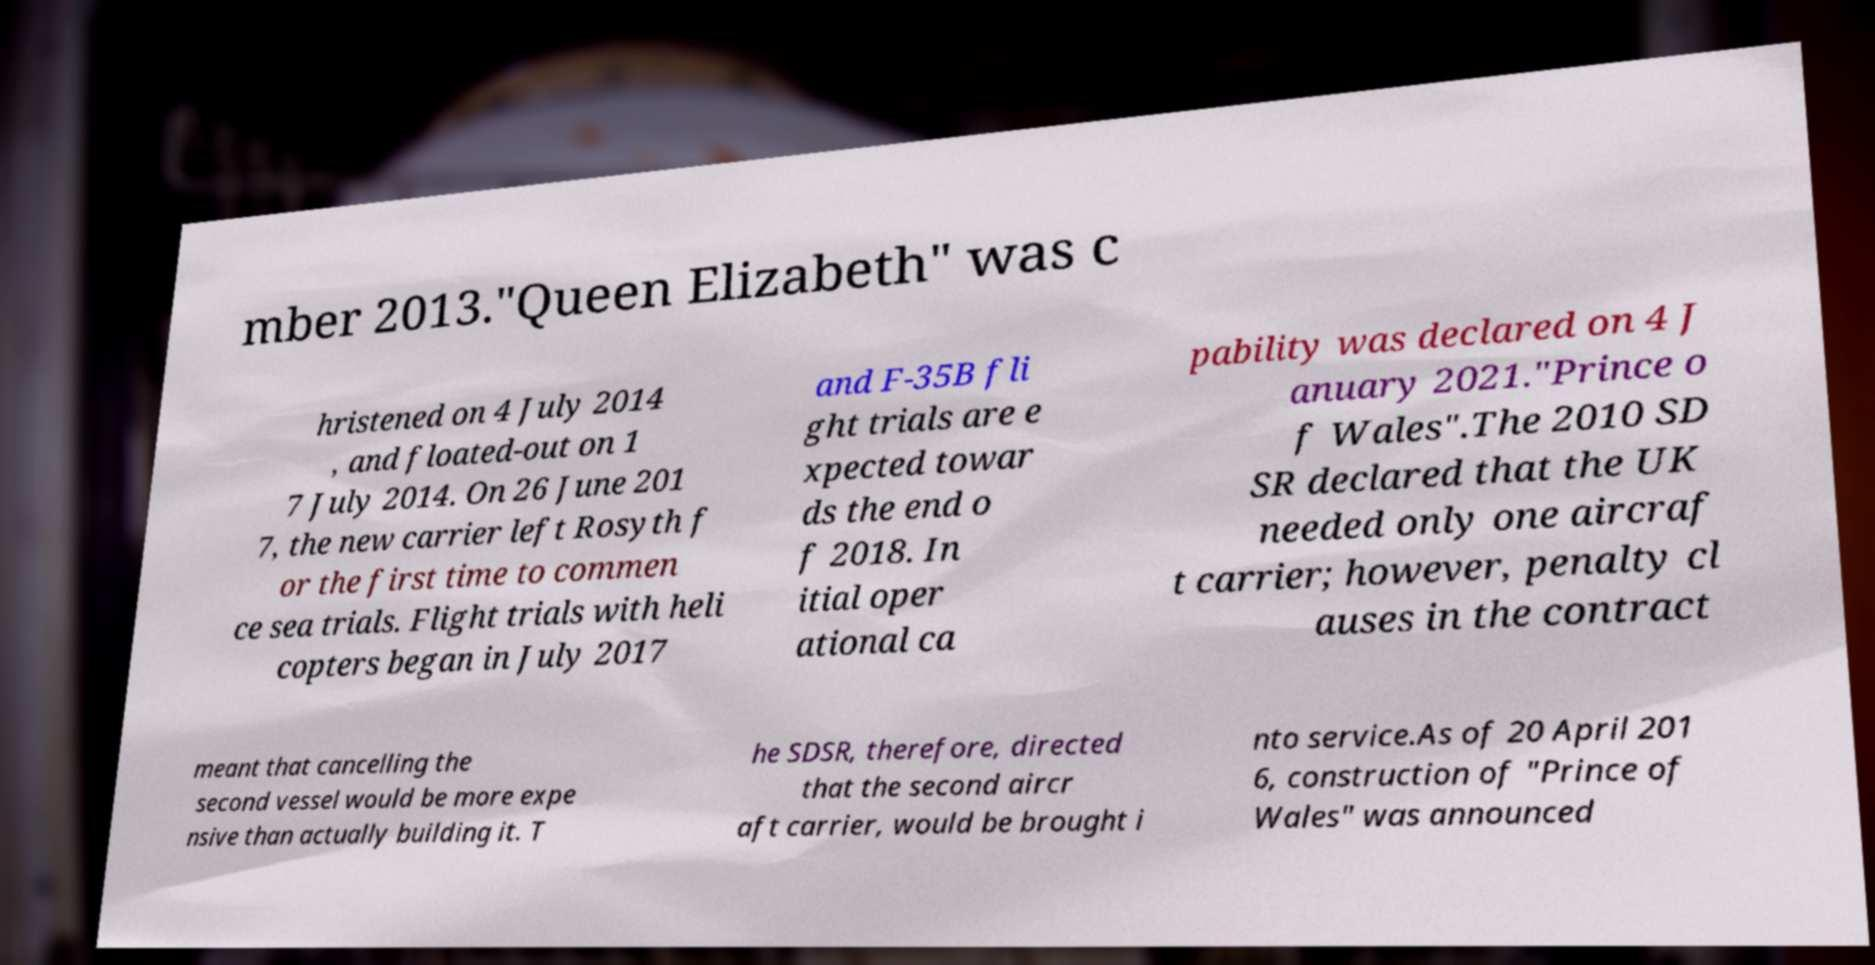Could you assist in decoding the text presented in this image and type it out clearly? mber 2013."Queen Elizabeth" was c hristened on 4 July 2014 , and floated-out on 1 7 July 2014. On 26 June 201 7, the new carrier left Rosyth f or the first time to commen ce sea trials. Flight trials with heli copters began in July 2017 and F-35B fli ght trials are e xpected towar ds the end o f 2018. In itial oper ational ca pability was declared on 4 J anuary 2021."Prince o f Wales".The 2010 SD SR declared that the UK needed only one aircraf t carrier; however, penalty cl auses in the contract meant that cancelling the second vessel would be more expe nsive than actually building it. T he SDSR, therefore, directed that the second aircr aft carrier, would be brought i nto service.As of 20 April 201 6, construction of "Prince of Wales" was announced 